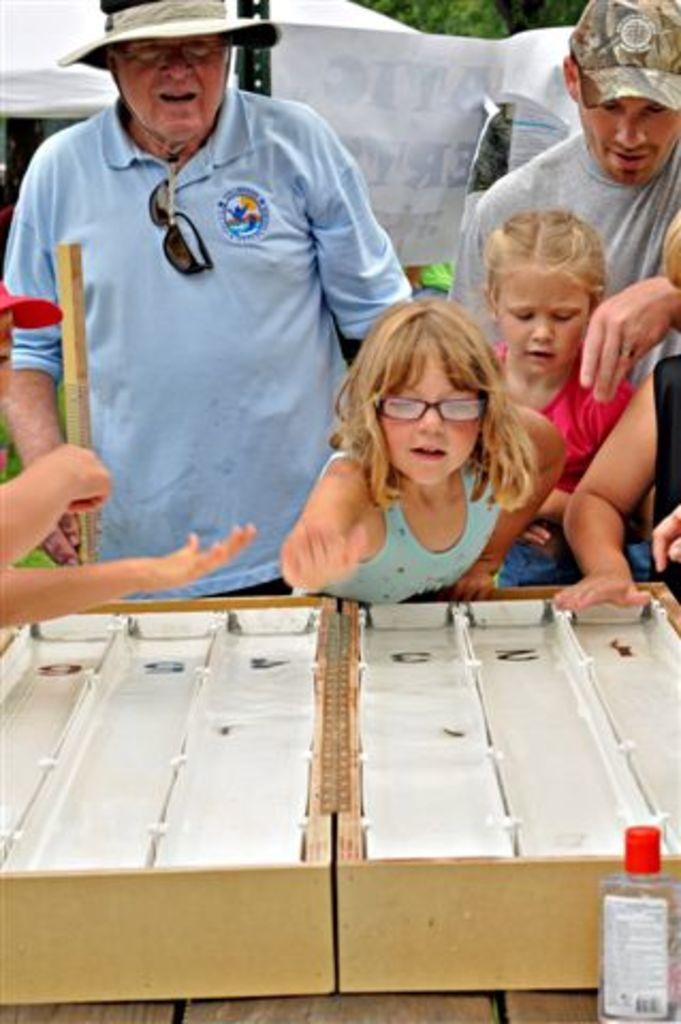Describe this image in one or two sentences. There are group of people standing in front of a table which consists of an wooden box on it. 